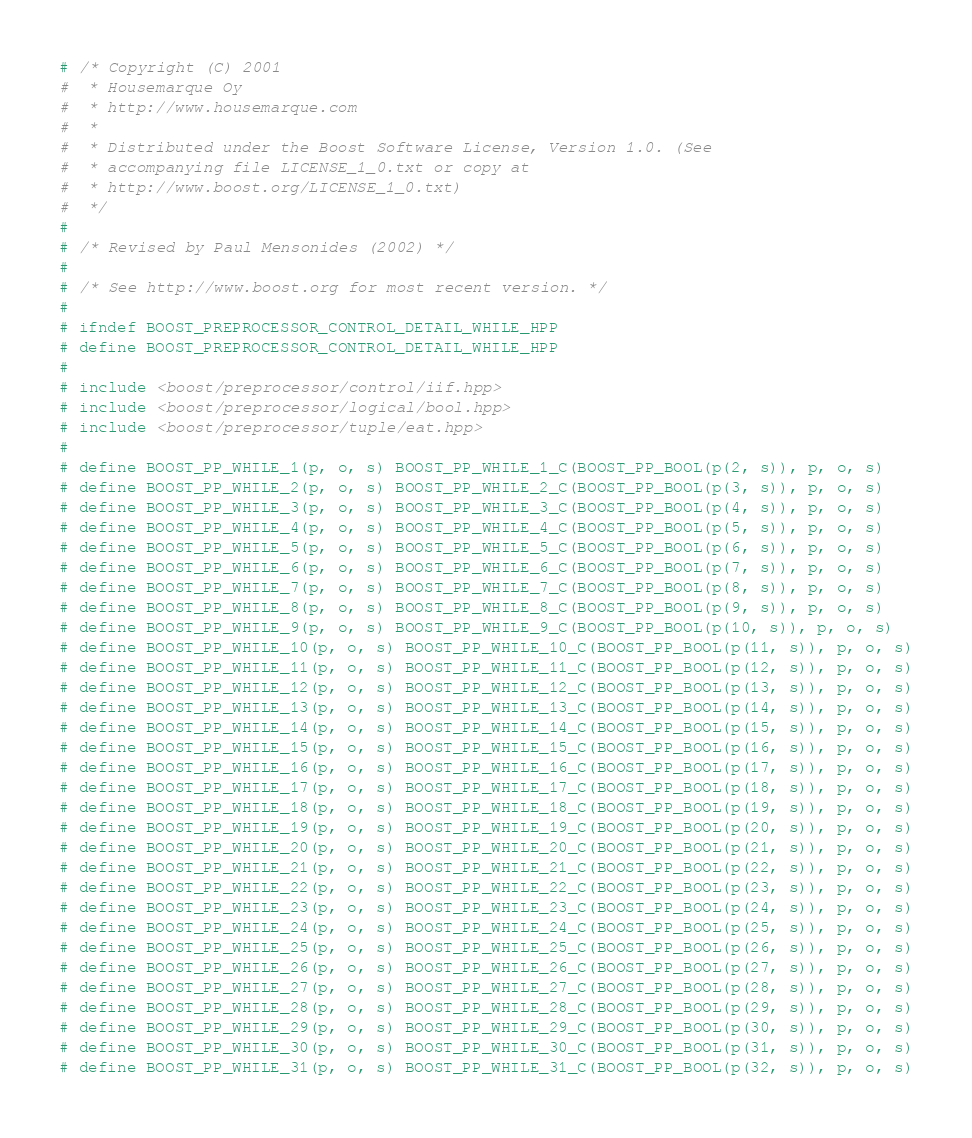Convert code to text. <code><loc_0><loc_0><loc_500><loc_500><_C++_># /* Copyright (C) 2001
#  * Housemarque Oy
#  * http://www.housemarque.com
#  *
#  * Distributed under the Boost Software License, Version 1.0. (See
#  * accompanying file LICENSE_1_0.txt or copy at
#  * http://www.boost.org/LICENSE_1_0.txt)
#  */
#
# /* Revised by Paul Mensonides (2002) */
#
# /* See http://www.boost.org for most recent version. */
#
# ifndef BOOST_PREPROCESSOR_CONTROL_DETAIL_WHILE_HPP
# define BOOST_PREPROCESSOR_CONTROL_DETAIL_WHILE_HPP
#
# include <boost/preprocessor/control/iif.hpp>
# include <boost/preprocessor/logical/bool.hpp>
# include <boost/preprocessor/tuple/eat.hpp>
#
# define BOOST_PP_WHILE_1(p, o, s) BOOST_PP_WHILE_1_C(BOOST_PP_BOOL(p(2, s)), p, o, s)
# define BOOST_PP_WHILE_2(p, o, s) BOOST_PP_WHILE_2_C(BOOST_PP_BOOL(p(3, s)), p, o, s)
# define BOOST_PP_WHILE_3(p, o, s) BOOST_PP_WHILE_3_C(BOOST_PP_BOOL(p(4, s)), p, o, s)
# define BOOST_PP_WHILE_4(p, o, s) BOOST_PP_WHILE_4_C(BOOST_PP_BOOL(p(5, s)), p, o, s)
# define BOOST_PP_WHILE_5(p, o, s) BOOST_PP_WHILE_5_C(BOOST_PP_BOOL(p(6, s)), p, o, s)
# define BOOST_PP_WHILE_6(p, o, s) BOOST_PP_WHILE_6_C(BOOST_PP_BOOL(p(7, s)), p, o, s)
# define BOOST_PP_WHILE_7(p, o, s) BOOST_PP_WHILE_7_C(BOOST_PP_BOOL(p(8, s)), p, o, s)
# define BOOST_PP_WHILE_8(p, o, s) BOOST_PP_WHILE_8_C(BOOST_PP_BOOL(p(9, s)), p, o, s)
# define BOOST_PP_WHILE_9(p, o, s) BOOST_PP_WHILE_9_C(BOOST_PP_BOOL(p(10, s)), p, o, s)
# define BOOST_PP_WHILE_10(p, o, s) BOOST_PP_WHILE_10_C(BOOST_PP_BOOL(p(11, s)), p, o, s)
# define BOOST_PP_WHILE_11(p, o, s) BOOST_PP_WHILE_11_C(BOOST_PP_BOOL(p(12, s)), p, o, s)
# define BOOST_PP_WHILE_12(p, o, s) BOOST_PP_WHILE_12_C(BOOST_PP_BOOL(p(13, s)), p, o, s)
# define BOOST_PP_WHILE_13(p, o, s) BOOST_PP_WHILE_13_C(BOOST_PP_BOOL(p(14, s)), p, o, s)
# define BOOST_PP_WHILE_14(p, o, s) BOOST_PP_WHILE_14_C(BOOST_PP_BOOL(p(15, s)), p, o, s)
# define BOOST_PP_WHILE_15(p, o, s) BOOST_PP_WHILE_15_C(BOOST_PP_BOOL(p(16, s)), p, o, s)
# define BOOST_PP_WHILE_16(p, o, s) BOOST_PP_WHILE_16_C(BOOST_PP_BOOL(p(17, s)), p, o, s)
# define BOOST_PP_WHILE_17(p, o, s) BOOST_PP_WHILE_17_C(BOOST_PP_BOOL(p(18, s)), p, o, s)
# define BOOST_PP_WHILE_18(p, o, s) BOOST_PP_WHILE_18_C(BOOST_PP_BOOL(p(19, s)), p, o, s)
# define BOOST_PP_WHILE_19(p, o, s) BOOST_PP_WHILE_19_C(BOOST_PP_BOOL(p(20, s)), p, o, s)
# define BOOST_PP_WHILE_20(p, o, s) BOOST_PP_WHILE_20_C(BOOST_PP_BOOL(p(21, s)), p, o, s)
# define BOOST_PP_WHILE_21(p, o, s) BOOST_PP_WHILE_21_C(BOOST_PP_BOOL(p(22, s)), p, o, s)
# define BOOST_PP_WHILE_22(p, o, s) BOOST_PP_WHILE_22_C(BOOST_PP_BOOL(p(23, s)), p, o, s)
# define BOOST_PP_WHILE_23(p, o, s) BOOST_PP_WHILE_23_C(BOOST_PP_BOOL(p(24, s)), p, o, s)
# define BOOST_PP_WHILE_24(p, o, s) BOOST_PP_WHILE_24_C(BOOST_PP_BOOL(p(25, s)), p, o, s)
# define BOOST_PP_WHILE_25(p, o, s) BOOST_PP_WHILE_25_C(BOOST_PP_BOOL(p(26, s)), p, o, s)
# define BOOST_PP_WHILE_26(p, o, s) BOOST_PP_WHILE_26_C(BOOST_PP_BOOL(p(27, s)), p, o, s)
# define BOOST_PP_WHILE_27(p, o, s) BOOST_PP_WHILE_27_C(BOOST_PP_BOOL(p(28, s)), p, o, s)
# define BOOST_PP_WHILE_28(p, o, s) BOOST_PP_WHILE_28_C(BOOST_PP_BOOL(p(29, s)), p, o, s)
# define BOOST_PP_WHILE_29(p, o, s) BOOST_PP_WHILE_29_C(BOOST_PP_BOOL(p(30, s)), p, o, s)
# define BOOST_PP_WHILE_30(p, o, s) BOOST_PP_WHILE_30_C(BOOST_PP_BOOL(p(31, s)), p, o, s)
# define BOOST_PP_WHILE_31(p, o, s) BOOST_PP_WHILE_31_C(BOOST_PP_BOOL(p(32, s)), p, o, s)</code> 